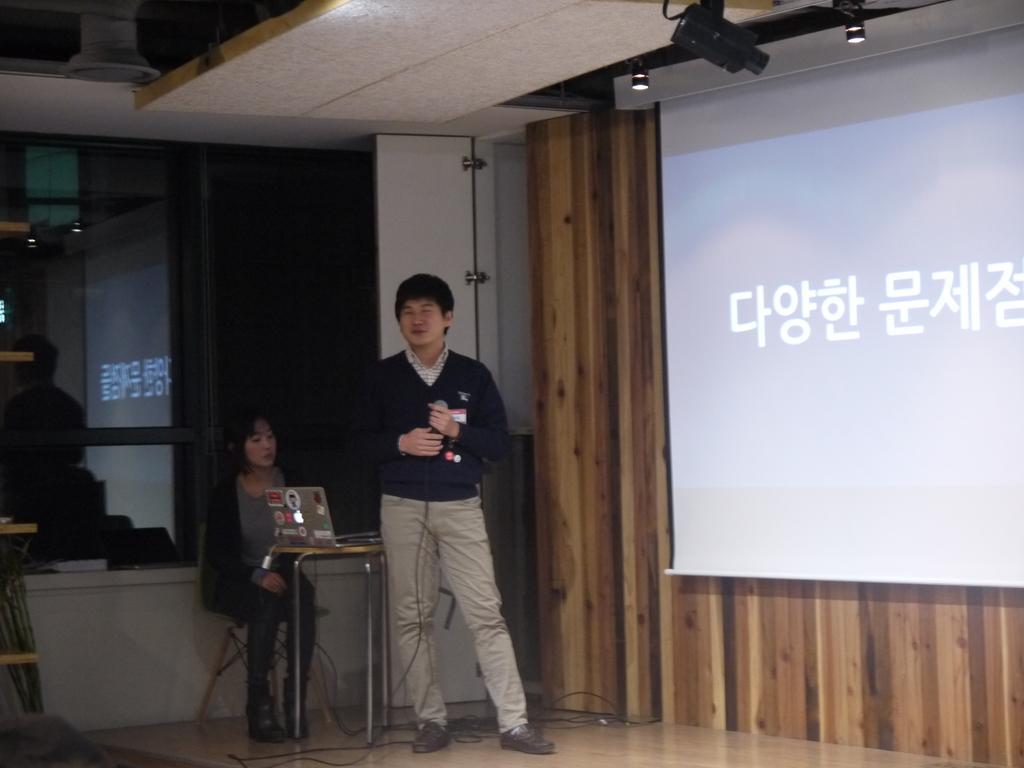Describe this image in one or two sentences. In this image in the center there is one person standing, and he is holding a mike. Beside him there is another woman who is sitting, and there is a table. On the table there is a laptop, at the bottom there is floor and some wires and on the right side of the image there is a screen and at the top there is projector and lights. And on the left side of the image there are glass doors and reflection of some persons and some objects, at the top there is ceiling. 